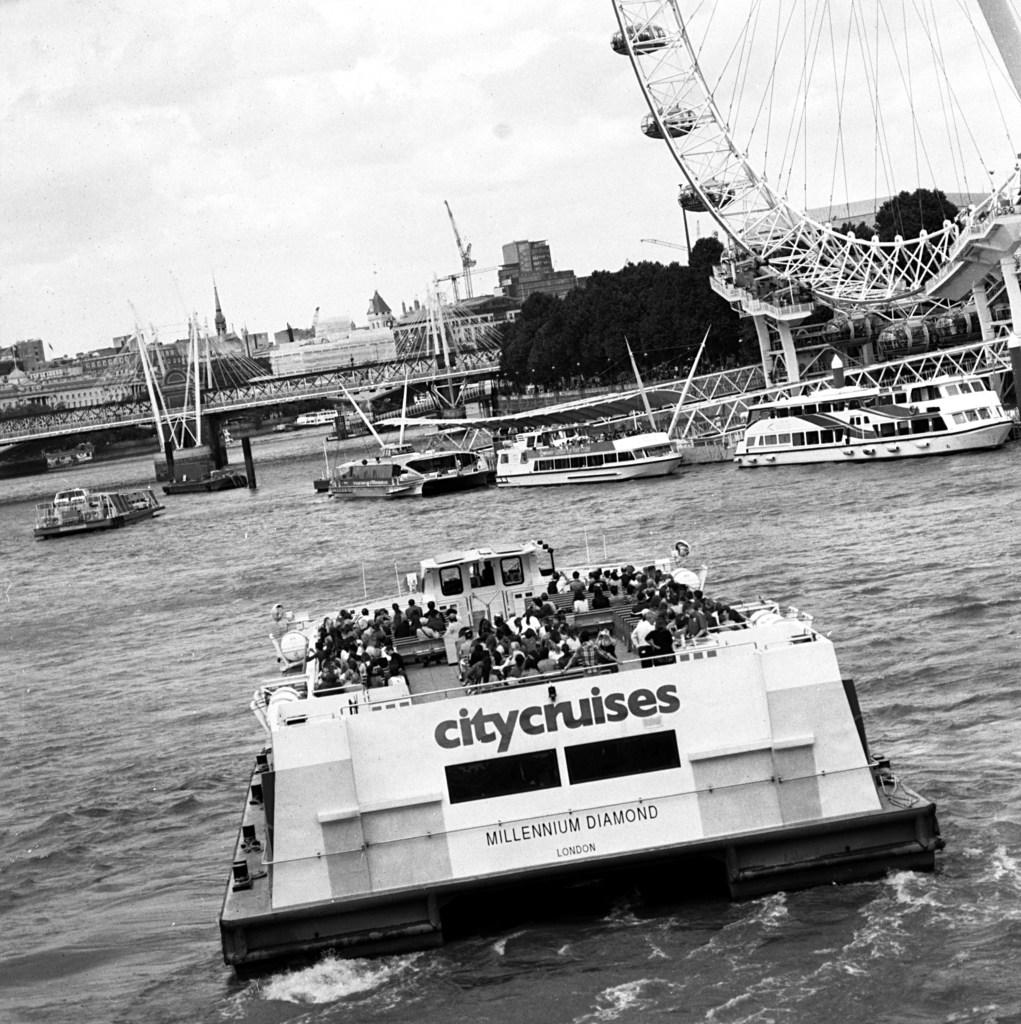Provide a one-sentence caption for the provided image. A black and white photo of a city cruise tour boat from London. 